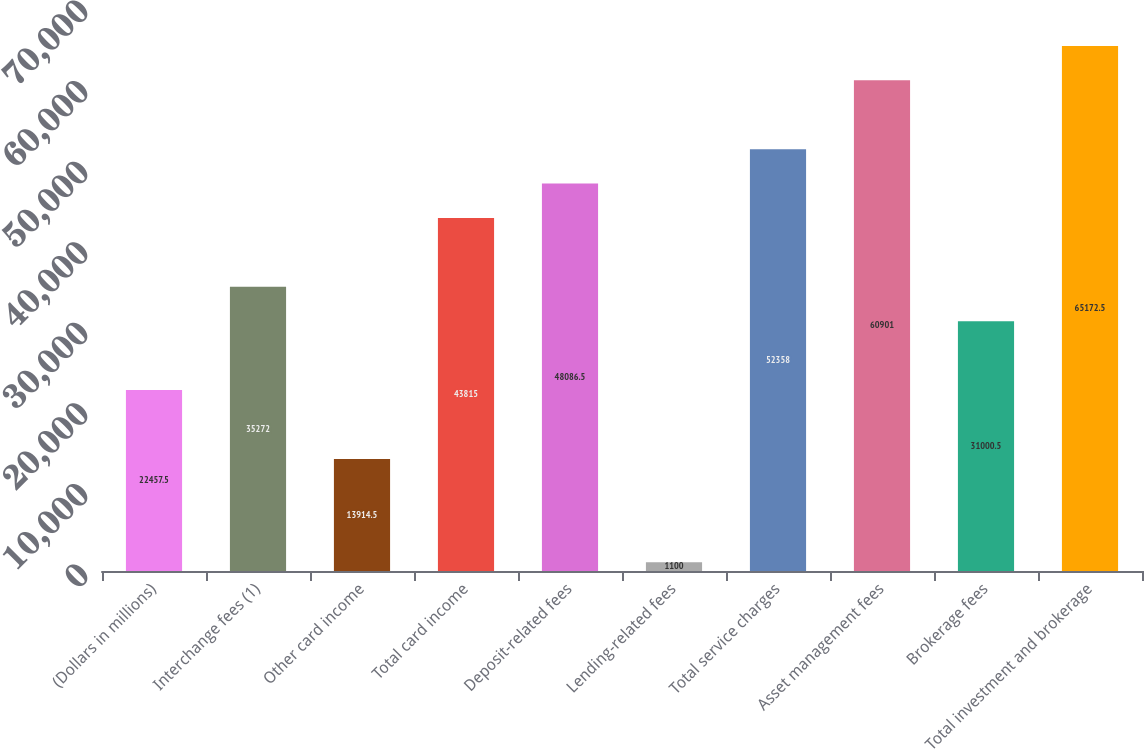Convert chart to OTSL. <chart><loc_0><loc_0><loc_500><loc_500><bar_chart><fcel>(Dollars in millions)<fcel>Interchange fees (1)<fcel>Other card income<fcel>Total card income<fcel>Deposit-related fees<fcel>Lending-related fees<fcel>Total service charges<fcel>Asset management fees<fcel>Brokerage fees<fcel>Total investment and brokerage<nl><fcel>22457.5<fcel>35272<fcel>13914.5<fcel>43815<fcel>48086.5<fcel>1100<fcel>52358<fcel>60901<fcel>31000.5<fcel>65172.5<nl></chart> 